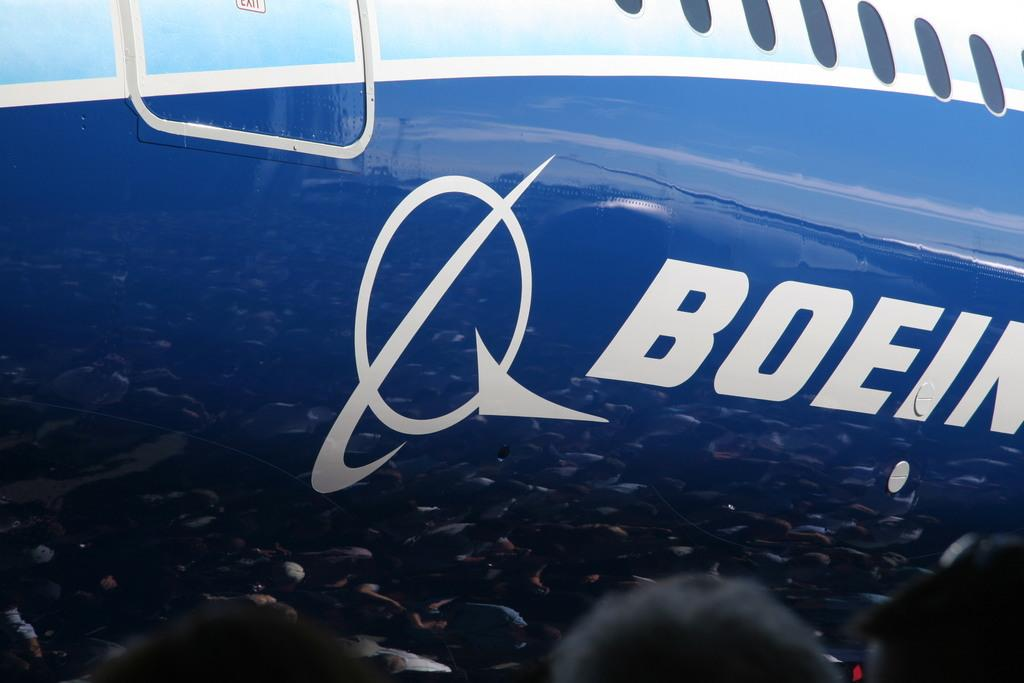<image>
Give a short and clear explanation of the subsequent image. A blue and white Boeing airplane has a white logo next to it's name. 